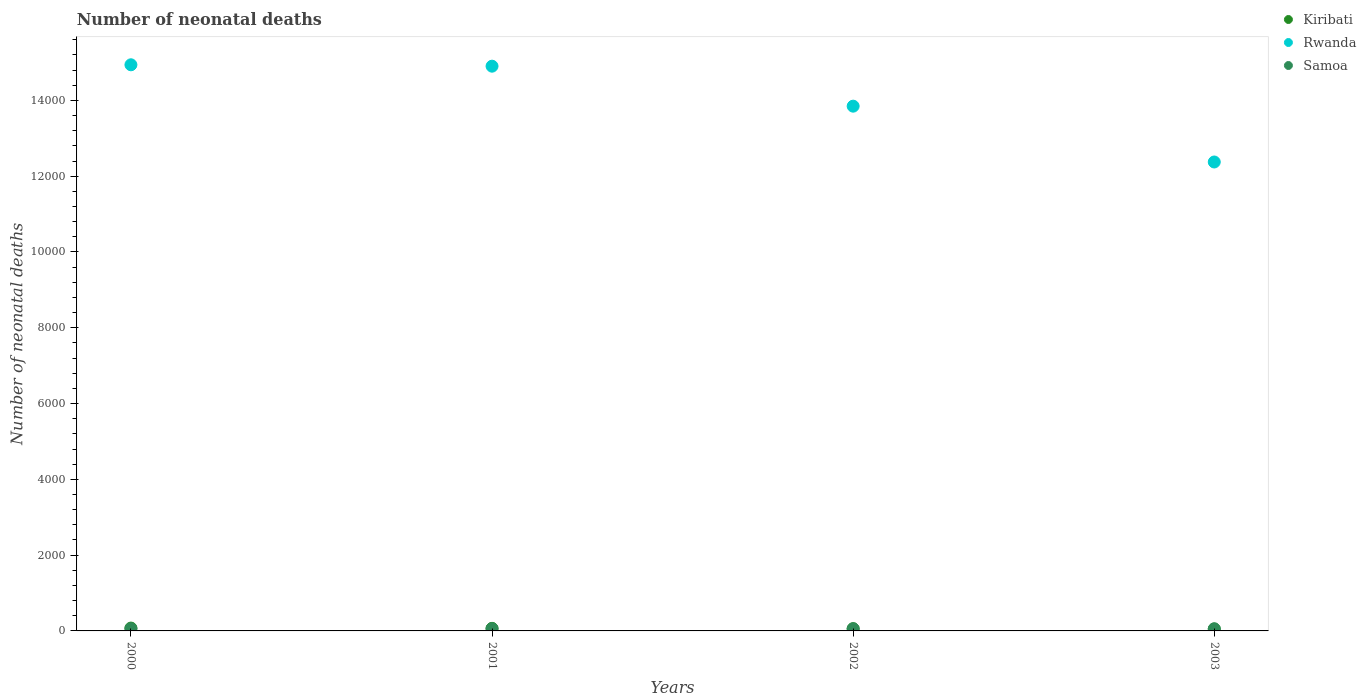How many different coloured dotlines are there?
Ensure brevity in your answer.  3. What is the number of neonatal deaths in in Rwanda in 2000?
Offer a very short reply. 1.49e+04. Across all years, what is the maximum number of neonatal deaths in in Rwanda?
Keep it short and to the point. 1.49e+04. Across all years, what is the minimum number of neonatal deaths in in Rwanda?
Your answer should be very brief. 1.24e+04. In which year was the number of neonatal deaths in in Samoa maximum?
Your answer should be very brief. 2000. What is the total number of neonatal deaths in in Kiribati in the graph?
Make the answer very short. 253. What is the difference between the number of neonatal deaths in in Kiribati in 2002 and that in 2003?
Offer a very short reply. 8. What is the difference between the number of neonatal deaths in in Samoa in 2001 and the number of neonatal deaths in in Rwanda in 2000?
Provide a short and direct response. -1.49e+04. What is the average number of neonatal deaths in in Kiribati per year?
Your answer should be very brief. 63.25. In the year 2002, what is the difference between the number of neonatal deaths in in Rwanda and number of neonatal deaths in in Samoa?
Offer a very short reply. 1.38e+04. In how many years, is the number of neonatal deaths in in Rwanda greater than 9600?
Make the answer very short. 4. What is the ratio of the number of neonatal deaths in in Samoa in 2000 to that in 2001?
Provide a succinct answer. 1.02. What is the difference between the highest and the second highest number of neonatal deaths in in Kiribati?
Offer a terse response. 7. What is the difference between the highest and the lowest number of neonatal deaths in in Samoa?
Your response must be concise. 3. Is the sum of the number of neonatal deaths in in Rwanda in 2000 and 2003 greater than the maximum number of neonatal deaths in in Kiribati across all years?
Keep it short and to the point. Yes. Does the number of neonatal deaths in in Samoa monotonically increase over the years?
Make the answer very short. No. Is the number of neonatal deaths in in Samoa strictly greater than the number of neonatal deaths in in Rwanda over the years?
Ensure brevity in your answer.  No. How many dotlines are there?
Your answer should be very brief. 3. What is the difference between two consecutive major ticks on the Y-axis?
Your response must be concise. 2000. Are the values on the major ticks of Y-axis written in scientific E-notation?
Make the answer very short. No. Does the graph contain any zero values?
Offer a very short reply. No. What is the title of the graph?
Keep it short and to the point. Number of neonatal deaths. Does "American Samoa" appear as one of the legend labels in the graph?
Your answer should be compact. No. What is the label or title of the Y-axis?
Your answer should be compact. Number of neonatal deaths. What is the Number of neonatal deaths of Rwanda in 2000?
Ensure brevity in your answer.  1.49e+04. What is the Number of neonatal deaths in Samoa in 2000?
Give a very brief answer. 59. What is the Number of neonatal deaths of Rwanda in 2001?
Offer a very short reply. 1.49e+04. What is the Number of neonatal deaths in Kiribati in 2002?
Keep it short and to the point. 59. What is the Number of neonatal deaths in Rwanda in 2002?
Provide a succinct answer. 1.38e+04. What is the Number of neonatal deaths of Samoa in 2002?
Keep it short and to the point. 57. What is the Number of neonatal deaths of Kiribati in 2003?
Offer a very short reply. 51. What is the Number of neonatal deaths in Rwanda in 2003?
Offer a terse response. 1.24e+04. What is the Number of neonatal deaths of Samoa in 2003?
Keep it short and to the point. 56. Across all years, what is the maximum Number of neonatal deaths in Kiribati?
Make the answer very short. 75. Across all years, what is the maximum Number of neonatal deaths of Rwanda?
Give a very brief answer. 1.49e+04. Across all years, what is the minimum Number of neonatal deaths of Kiribati?
Make the answer very short. 51. Across all years, what is the minimum Number of neonatal deaths of Rwanda?
Keep it short and to the point. 1.24e+04. What is the total Number of neonatal deaths of Kiribati in the graph?
Your answer should be compact. 253. What is the total Number of neonatal deaths of Rwanda in the graph?
Keep it short and to the point. 5.61e+04. What is the total Number of neonatal deaths of Samoa in the graph?
Provide a succinct answer. 230. What is the difference between the Number of neonatal deaths of Kiribati in 2000 and that in 2001?
Make the answer very short. 7. What is the difference between the Number of neonatal deaths of Rwanda in 2000 and that in 2001?
Provide a short and direct response. 37. What is the difference between the Number of neonatal deaths of Kiribati in 2000 and that in 2002?
Give a very brief answer. 16. What is the difference between the Number of neonatal deaths in Rwanda in 2000 and that in 2002?
Keep it short and to the point. 1092. What is the difference between the Number of neonatal deaths of Samoa in 2000 and that in 2002?
Your response must be concise. 2. What is the difference between the Number of neonatal deaths of Rwanda in 2000 and that in 2003?
Your answer should be very brief. 2565. What is the difference between the Number of neonatal deaths of Samoa in 2000 and that in 2003?
Make the answer very short. 3. What is the difference between the Number of neonatal deaths in Kiribati in 2001 and that in 2002?
Provide a short and direct response. 9. What is the difference between the Number of neonatal deaths of Rwanda in 2001 and that in 2002?
Make the answer very short. 1055. What is the difference between the Number of neonatal deaths of Samoa in 2001 and that in 2002?
Keep it short and to the point. 1. What is the difference between the Number of neonatal deaths in Kiribati in 2001 and that in 2003?
Your answer should be very brief. 17. What is the difference between the Number of neonatal deaths in Rwanda in 2001 and that in 2003?
Offer a terse response. 2528. What is the difference between the Number of neonatal deaths in Rwanda in 2002 and that in 2003?
Your response must be concise. 1473. What is the difference between the Number of neonatal deaths of Kiribati in 2000 and the Number of neonatal deaths of Rwanda in 2001?
Provide a short and direct response. -1.48e+04. What is the difference between the Number of neonatal deaths of Kiribati in 2000 and the Number of neonatal deaths of Samoa in 2001?
Provide a succinct answer. 17. What is the difference between the Number of neonatal deaths in Rwanda in 2000 and the Number of neonatal deaths in Samoa in 2001?
Offer a terse response. 1.49e+04. What is the difference between the Number of neonatal deaths of Kiribati in 2000 and the Number of neonatal deaths of Rwanda in 2002?
Give a very brief answer. -1.38e+04. What is the difference between the Number of neonatal deaths in Kiribati in 2000 and the Number of neonatal deaths in Samoa in 2002?
Provide a short and direct response. 18. What is the difference between the Number of neonatal deaths in Rwanda in 2000 and the Number of neonatal deaths in Samoa in 2002?
Your response must be concise. 1.49e+04. What is the difference between the Number of neonatal deaths in Kiribati in 2000 and the Number of neonatal deaths in Rwanda in 2003?
Keep it short and to the point. -1.23e+04. What is the difference between the Number of neonatal deaths of Rwanda in 2000 and the Number of neonatal deaths of Samoa in 2003?
Offer a terse response. 1.49e+04. What is the difference between the Number of neonatal deaths in Kiribati in 2001 and the Number of neonatal deaths in Rwanda in 2002?
Your answer should be very brief. -1.38e+04. What is the difference between the Number of neonatal deaths of Kiribati in 2001 and the Number of neonatal deaths of Samoa in 2002?
Give a very brief answer. 11. What is the difference between the Number of neonatal deaths in Rwanda in 2001 and the Number of neonatal deaths in Samoa in 2002?
Ensure brevity in your answer.  1.48e+04. What is the difference between the Number of neonatal deaths in Kiribati in 2001 and the Number of neonatal deaths in Rwanda in 2003?
Provide a short and direct response. -1.23e+04. What is the difference between the Number of neonatal deaths in Kiribati in 2001 and the Number of neonatal deaths in Samoa in 2003?
Make the answer very short. 12. What is the difference between the Number of neonatal deaths in Rwanda in 2001 and the Number of neonatal deaths in Samoa in 2003?
Offer a very short reply. 1.48e+04. What is the difference between the Number of neonatal deaths of Kiribati in 2002 and the Number of neonatal deaths of Rwanda in 2003?
Provide a short and direct response. -1.23e+04. What is the difference between the Number of neonatal deaths of Rwanda in 2002 and the Number of neonatal deaths of Samoa in 2003?
Keep it short and to the point. 1.38e+04. What is the average Number of neonatal deaths of Kiribati per year?
Give a very brief answer. 63.25. What is the average Number of neonatal deaths in Rwanda per year?
Offer a terse response. 1.40e+04. What is the average Number of neonatal deaths of Samoa per year?
Ensure brevity in your answer.  57.5. In the year 2000, what is the difference between the Number of neonatal deaths in Kiribati and Number of neonatal deaths in Rwanda?
Provide a succinct answer. -1.49e+04. In the year 2000, what is the difference between the Number of neonatal deaths in Kiribati and Number of neonatal deaths in Samoa?
Keep it short and to the point. 16. In the year 2000, what is the difference between the Number of neonatal deaths in Rwanda and Number of neonatal deaths in Samoa?
Make the answer very short. 1.49e+04. In the year 2001, what is the difference between the Number of neonatal deaths of Kiribati and Number of neonatal deaths of Rwanda?
Your answer should be very brief. -1.48e+04. In the year 2001, what is the difference between the Number of neonatal deaths in Rwanda and Number of neonatal deaths in Samoa?
Provide a succinct answer. 1.48e+04. In the year 2002, what is the difference between the Number of neonatal deaths in Kiribati and Number of neonatal deaths in Rwanda?
Offer a very short reply. -1.38e+04. In the year 2002, what is the difference between the Number of neonatal deaths in Kiribati and Number of neonatal deaths in Samoa?
Your response must be concise. 2. In the year 2002, what is the difference between the Number of neonatal deaths of Rwanda and Number of neonatal deaths of Samoa?
Offer a terse response. 1.38e+04. In the year 2003, what is the difference between the Number of neonatal deaths in Kiribati and Number of neonatal deaths in Rwanda?
Provide a succinct answer. -1.23e+04. In the year 2003, what is the difference between the Number of neonatal deaths of Kiribati and Number of neonatal deaths of Samoa?
Offer a very short reply. -5. In the year 2003, what is the difference between the Number of neonatal deaths of Rwanda and Number of neonatal deaths of Samoa?
Offer a very short reply. 1.23e+04. What is the ratio of the Number of neonatal deaths in Kiribati in 2000 to that in 2001?
Ensure brevity in your answer.  1.1. What is the ratio of the Number of neonatal deaths in Rwanda in 2000 to that in 2001?
Provide a short and direct response. 1. What is the ratio of the Number of neonatal deaths of Samoa in 2000 to that in 2001?
Your response must be concise. 1.02. What is the ratio of the Number of neonatal deaths in Kiribati in 2000 to that in 2002?
Offer a terse response. 1.27. What is the ratio of the Number of neonatal deaths of Rwanda in 2000 to that in 2002?
Ensure brevity in your answer.  1.08. What is the ratio of the Number of neonatal deaths in Samoa in 2000 to that in 2002?
Offer a very short reply. 1.04. What is the ratio of the Number of neonatal deaths of Kiribati in 2000 to that in 2003?
Provide a succinct answer. 1.47. What is the ratio of the Number of neonatal deaths in Rwanda in 2000 to that in 2003?
Your answer should be very brief. 1.21. What is the ratio of the Number of neonatal deaths in Samoa in 2000 to that in 2003?
Offer a terse response. 1.05. What is the ratio of the Number of neonatal deaths of Kiribati in 2001 to that in 2002?
Offer a terse response. 1.15. What is the ratio of the Number of neonatal deaths in Rwanda in 2001 to that in 2002?
Provide a succinct answer. 1.08. What is the ratio of the Number of neonatal deaths in Samoa in 2001 to that in 2002?
Offer a very short reply. 1.02. What is the ratio of the Number of neonatal deaths in Kiribati in 2001 to that in 2003?
Provide a succinct answer. 1.33. What is the ratio of the Number of neonatal deaths of Rwanda in 2001 to that in 2003?
Your response must be concise. 1.2. What is the ratio of the Number of neonatal deaths in Samoa in 2001 to that in 2003?
Give a very brief answer. 1.04. What is the ratio of the Number of neonatal deaths of Kiribati in 2002 to that in 2003?
Your response must be concise. 1.16. What is the ratio of the Number of neonatal deaths in Rwanda in 2002 to that in 2003?
Offer a terse response. 1.12. What is the ratio of the Number of neonatal deaths of Samoa in 2002 to that in 2003?
Keep it short and to the point. 1.02. What is the difference between the highest and the second highest Number of neonatal deaths in Kiribati?
Your response must be concise. 7. What is the difference between the highest and the second highest Number of neonatal deaths of Samoa?
Provide a succinct answer. 1. What is the difference between the highest and the lowest Number of neonatal deaths in Kiribati?
Provide a short and direct response. 24. What is the difference between the highest and the lowest Number of neonatal deaths of Rwanda?
Provide a succinct answer. 2565. What is the difference between the highest and the lowest Number of neonatal deaths in Samoa?
Your answer should be compact. 3. 